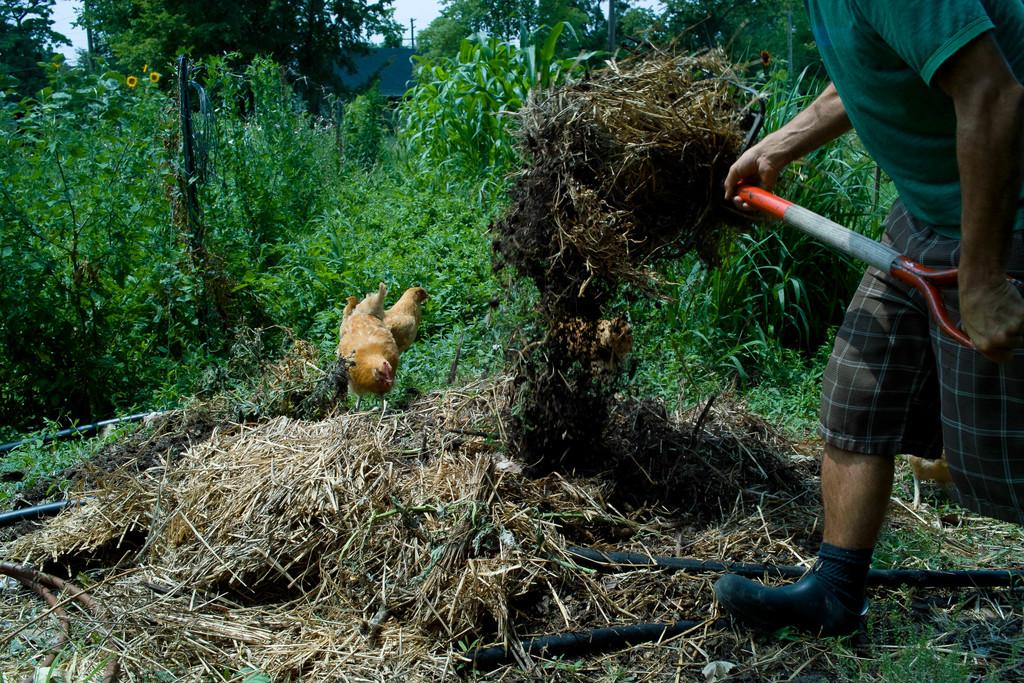Who is present in the image? There is a man in the image. What is the man holding in his hands? The man is holding a tool in his hands. What type of environment is visible in the image? There is grass visible in the image. How many hens can be seen in the image? There are 2 hens in the image. What can be seen in the background of the image? There are plants and trees in the background of the image. What type of street can be seen in the image? There is no street present in the image; it features a man holding a tool, grass, hens, plants, and trees. How does the steam escape from the man's tool in the image? There is no steam present in the image, nor is there a tool that would produce steam. 